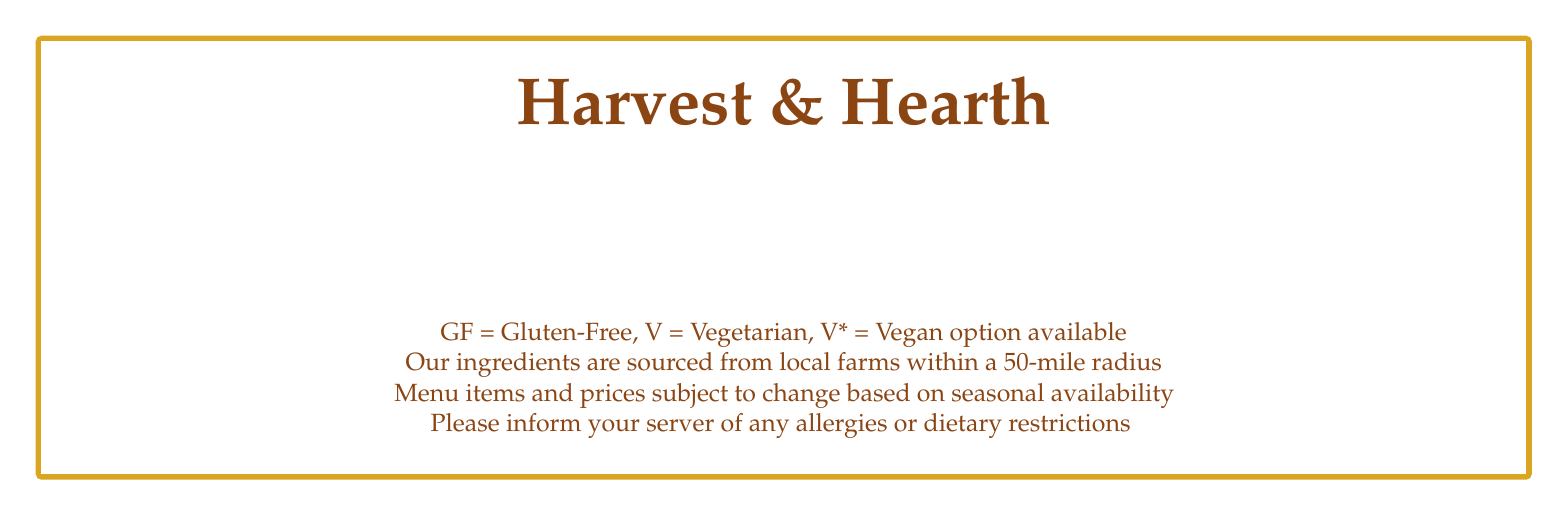What is the name of the restaurant? The name of the restaurant is prominently displayed in the header of the menu.
Answer: Harvest & Hearth What is the price of the Pan-Seared Rainbow Trout? The price is located next to the menu item for the Pan-Seared Rainbow Trout.
Answer: $26 What type of cuisine does this menu represent? The menu indicates it features farm-to-table with locally-sourced ingredients.
Answer: Farm-to-table How many seasonal starters are listed on the menu? The number of items can be counted from the section titled Seasonal Starters.
Answer: 2 Which dish has a vegan option available? By looking for items marked with "V*" indicating a vegan option available.
Answer: Harvest Vegetable Risotto What is the main ingredient in the Roasted Butternut Squash Soup? The main ingredient is mentioned in the description of the soup menu item.
Answer: Butternut Squash What dietary restriction is indicated for the Apple Cider Donuts? The dietary restriction is specified next to the dessert in the menu.
Answer: V (Vegetarian) What does GF stand for in this menu? The abbreviation is defined in the footnotes at the bottom of the menu.
Answer: Gluten-Free How are the ingredients sourced for the menu items? The sourcing details are provided in the footnote explaining the ingredients.
Answer: Local farms within a 50-mile radius 